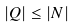<formula> <loc_0><loc_0><loc_500><loc_500>| Q | \leq | N |</formula> 